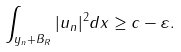<formula> <loc_0><loc_0><loc_500><loc_500>\int _ { y _ { n } + B _ { R } } | u _ { n } | ^ { 2 } d x \geq c - \varepsilon .</formula> 